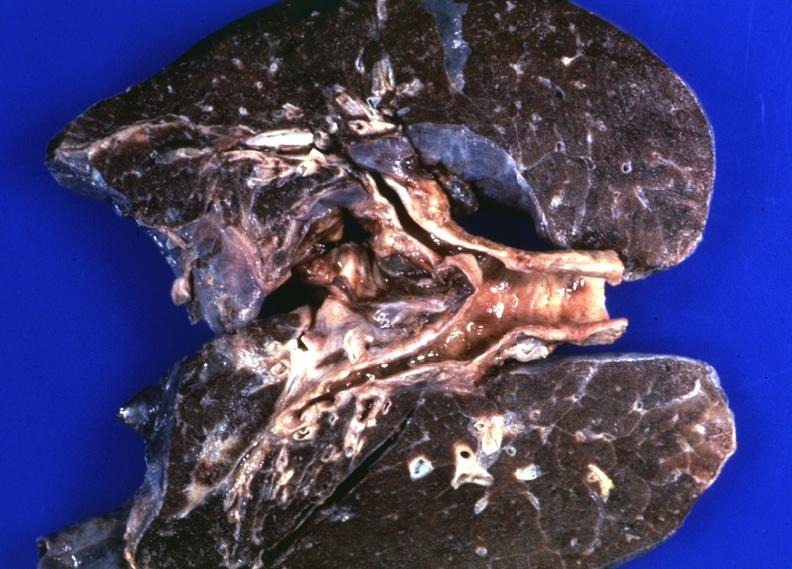s embryo-fetus present?
Answer the question using a single word or phrase. No 